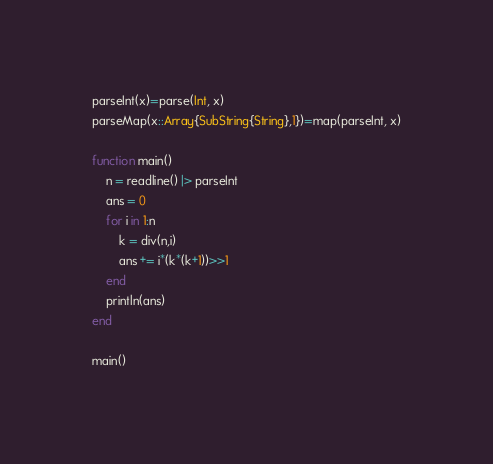Convert code to text. <code><loc_0><loc_0><loc_500><loc_500><_Julia_>parseInt(x)=parse(Int, x)
parseMap(x::Array{SubString{String},1})=map(parseInt, x)

function main()
	n = readline() |> parseInt
	ans = 0
	for i in 1:n
		k = div(n,i)
		ans += i*(k*(k+1))>>1
	end
	println(ans)
end

main()</code> 